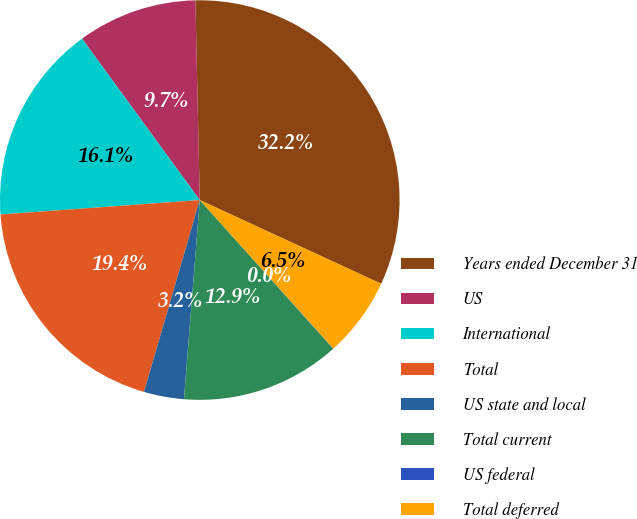Convert chart. <chart><loc_0><loc_0><loc_500><loc_500><pie_chart><fcel>Years ended December 31<fcel>US<fcel>International<fcel>Total<fcel>US state and local<fcel>Total current<fcel>US federal<fcel>Total deferred<nl><fcel>32.23%<fcel>9.68%<fcel>16.12%<fcel>19.35%<fcel>3.24%<fcel>12.9%<fcel>0.02%<fcel>6.46%<nl></chart> 